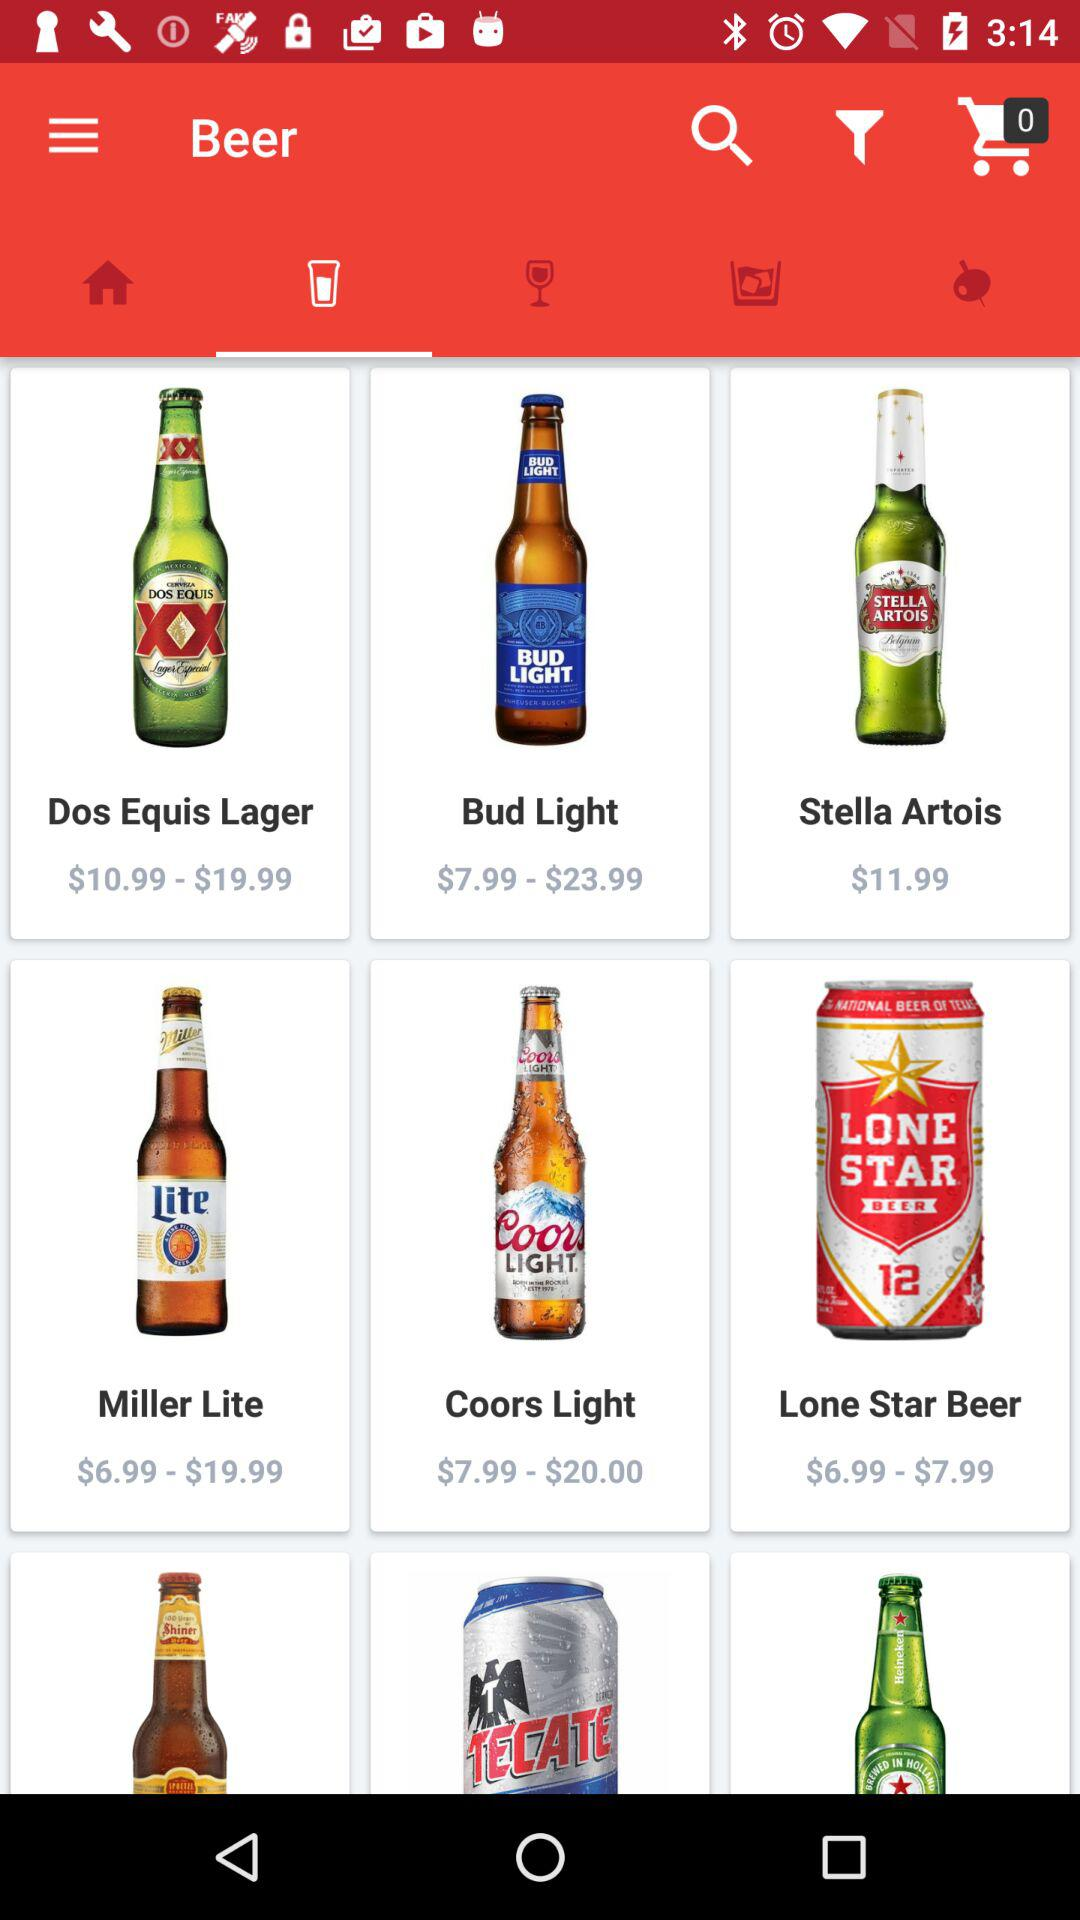What is the price of "Stella Artois" beer? The price is $11.99. 